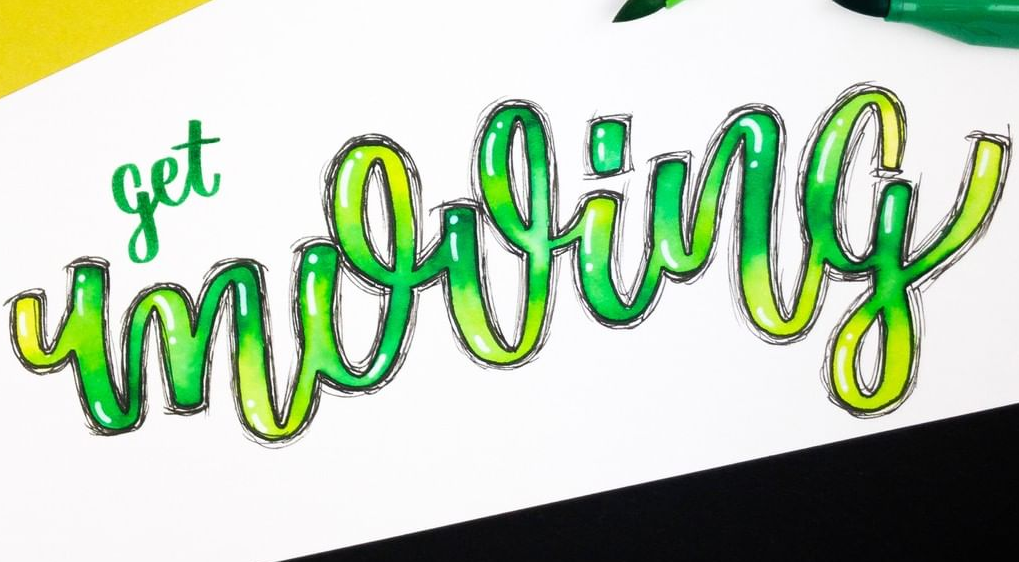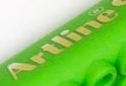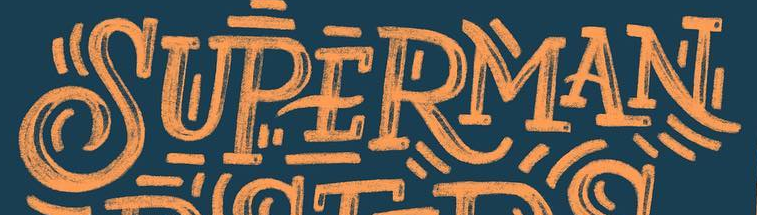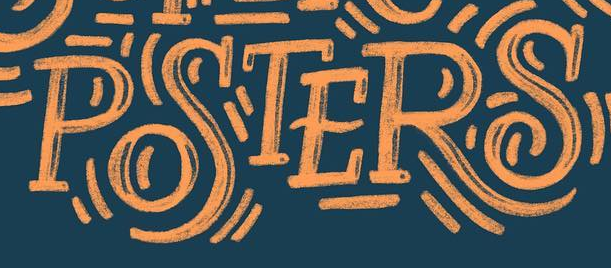Read the text from these images in sequence, separated by a semicolon. mooing; Artline; SUPERMAN; POSTERS 